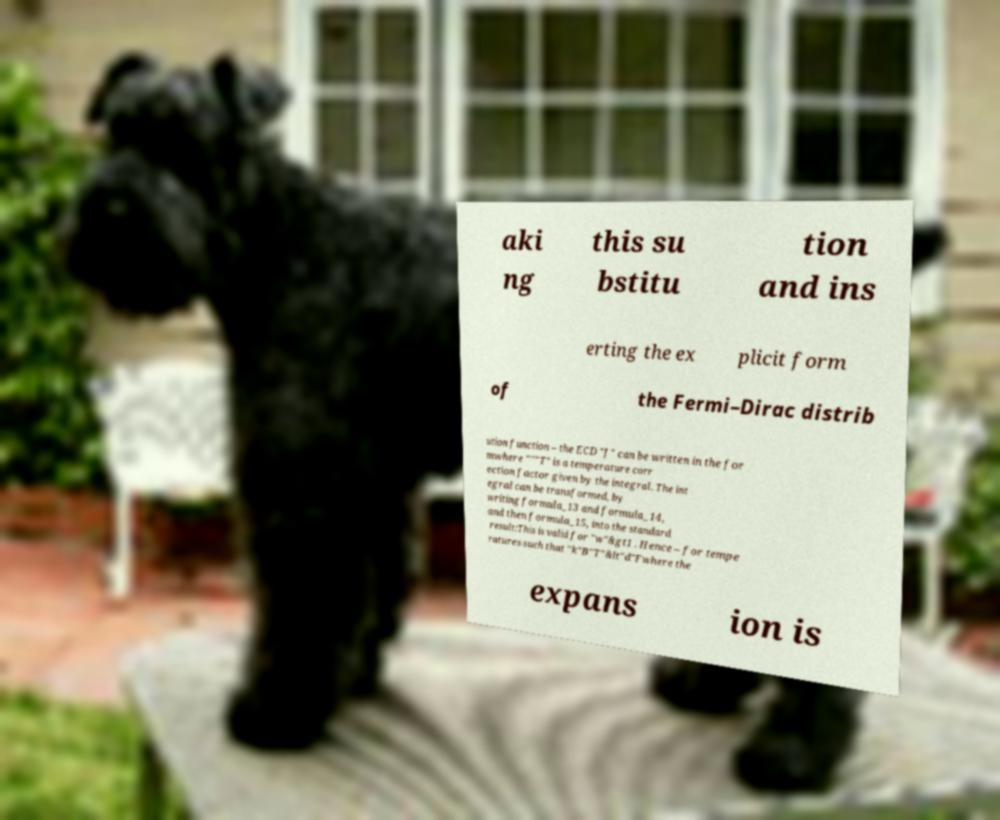I need the written content from this picture converted into text. Can you do that? aki ng this su bstitu tion and ins erting the ex plicit form of the Fermi–Dirac distrib ution function – the ECD "J" can be written in the for mwhere """T" is a temperature corr ection factor given by the integral. The int egral can be transformed, by writing formula_13 and formula_14, and then formula_15, into the standard result:This is valid for "w"&gt1 . Hence – for tempe ratures such that "k"B"T"&lt"d"Fwhere the expans ion is 